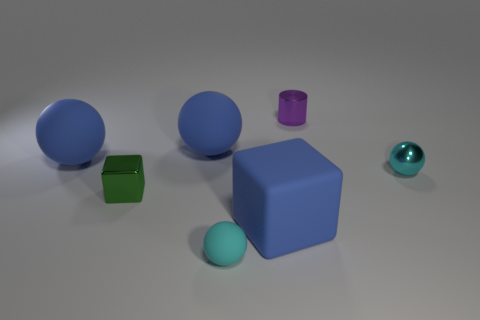What material is the thing that is the same color as the tiny metal sphere?
Your response must be concise. Rubber. There is a shiny thing behind the cyan shiny thing; what is its size?
Make the answer very short. Small. Is the number of small matte objects to the right of the tiny purple cylinder less than the number of tiny cyan objects?
Your answer should be compact. Yes. Is the color of the small cylinder the same as the shiny cube?
Offer a terse response. No. Is there any other thing that has the same shape as the small green object?
Your answer should be very brief. Yes. Is the number of tiny green blocks less than the number of small blue matte cubes?
Make the answer very short. No. There is a small ball that is behind the shiny object to the left of the cylinder; what is its color?
Offer a terse response. Cyan. The cyan ball behind the big blue rubber object that is in front of the small cyan ball that is to the right of the small matte object is made of what material?
Provide a succinct answer. Metal. There is a ball to the right of the cylinder; is its size the same as the cyan rubber thing?
Give a very brief answer. Yes. There is a block behind the big blue block; what material is it?
Keep it short and to the point. Metal. 